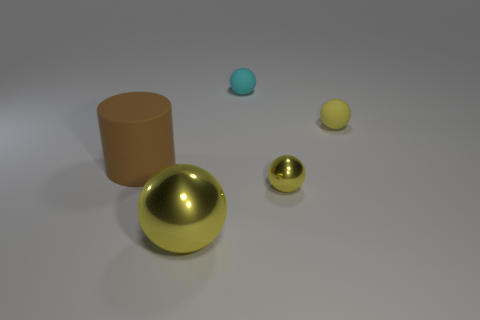There is a yellow object that is both right of the big metal ball and in front of the large brown matte thing; what is its size? The yellow object to the right of the golden metal sphere and in front of the large brown cylinder is medium-sized compared to the other objects visible in the image. 